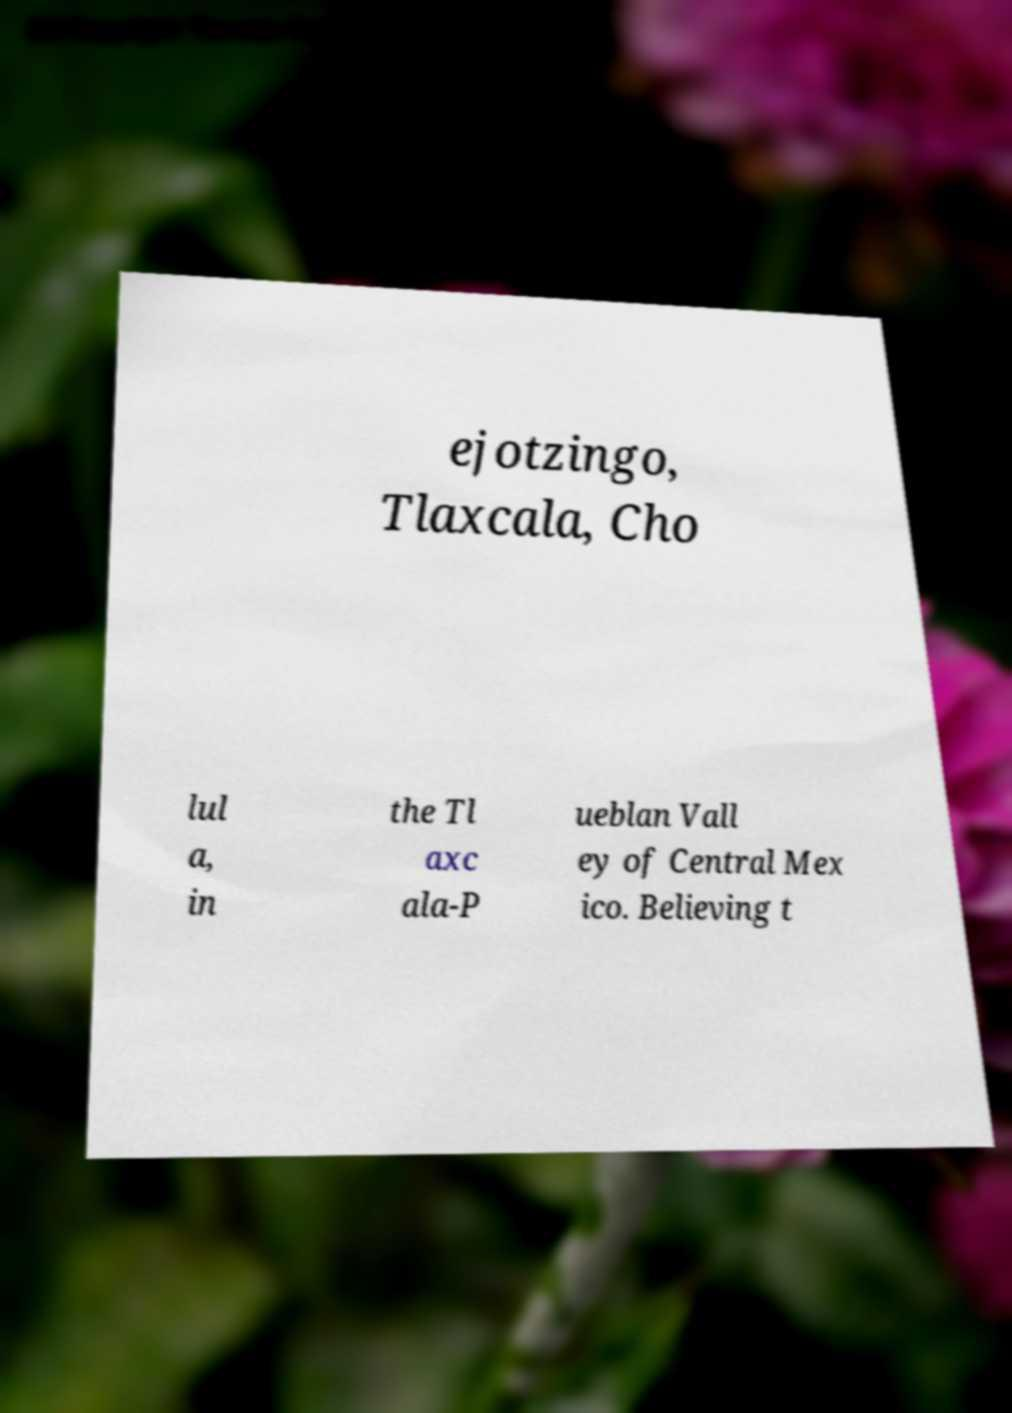Can you accurately transcribe the text from the provided image for me? ejotzingo, Tlaxcala, Cho lul a, in the Tl axc ala-P ueblan Vall ey of Central Mex ico. Believing t 